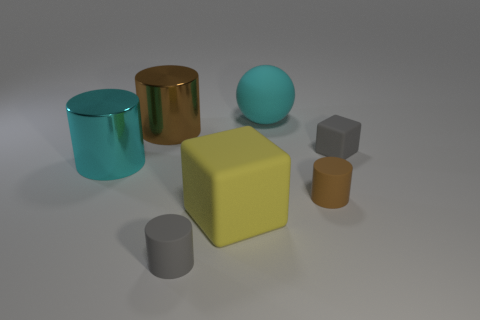Add 1 rubber objects. How many objects exist? 8 Subtract all cubes. How many objects are left? 5 Add 6 small gray cubes. How many small gray cubes are left? 7 Add 3 big matte things. How many big matte things exist? 5 Subtract 0 yellow cylinders. How many objects are left? 7 Subtract all large green cylinders. Subtract all big cyan objects. How many objects are left? 5 